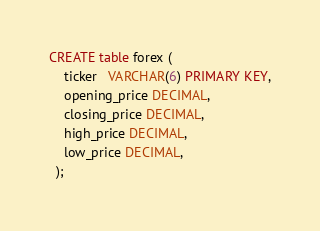<code> <loc_0><loc_0><loc_500><loc_500><_SQL_>CREATE table forex (
    ticker   VARCHAR(6) PRIMARY KEY,
    opening_price DECIMAL,
    closing_price DECIMAL,
    high_price DECIMAL,
    low_price DECIMAL,            
  );</code> 